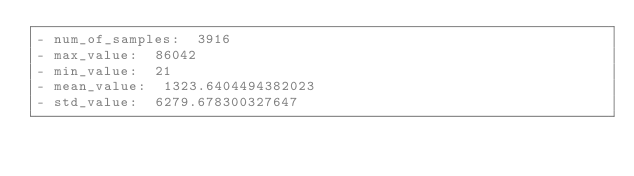Convert code to text. <code><loc_0><loc_0><loc_500><loc_500><_YAML_>- num_of_samples:  3916
- max_value:  86042
- min_value:  21
- mean_value:  1323.6404494382023
- std_value:  6279.678300327647
</code> 